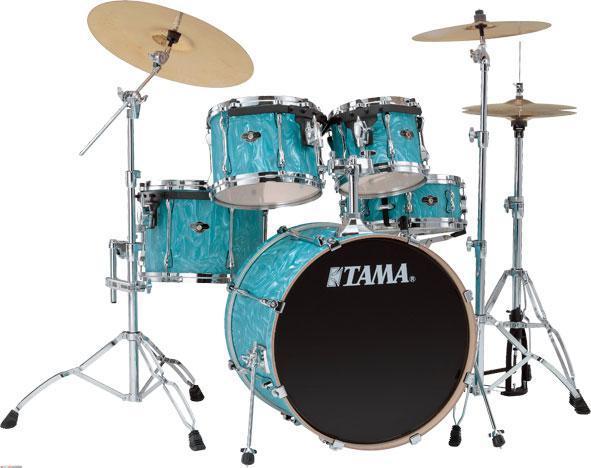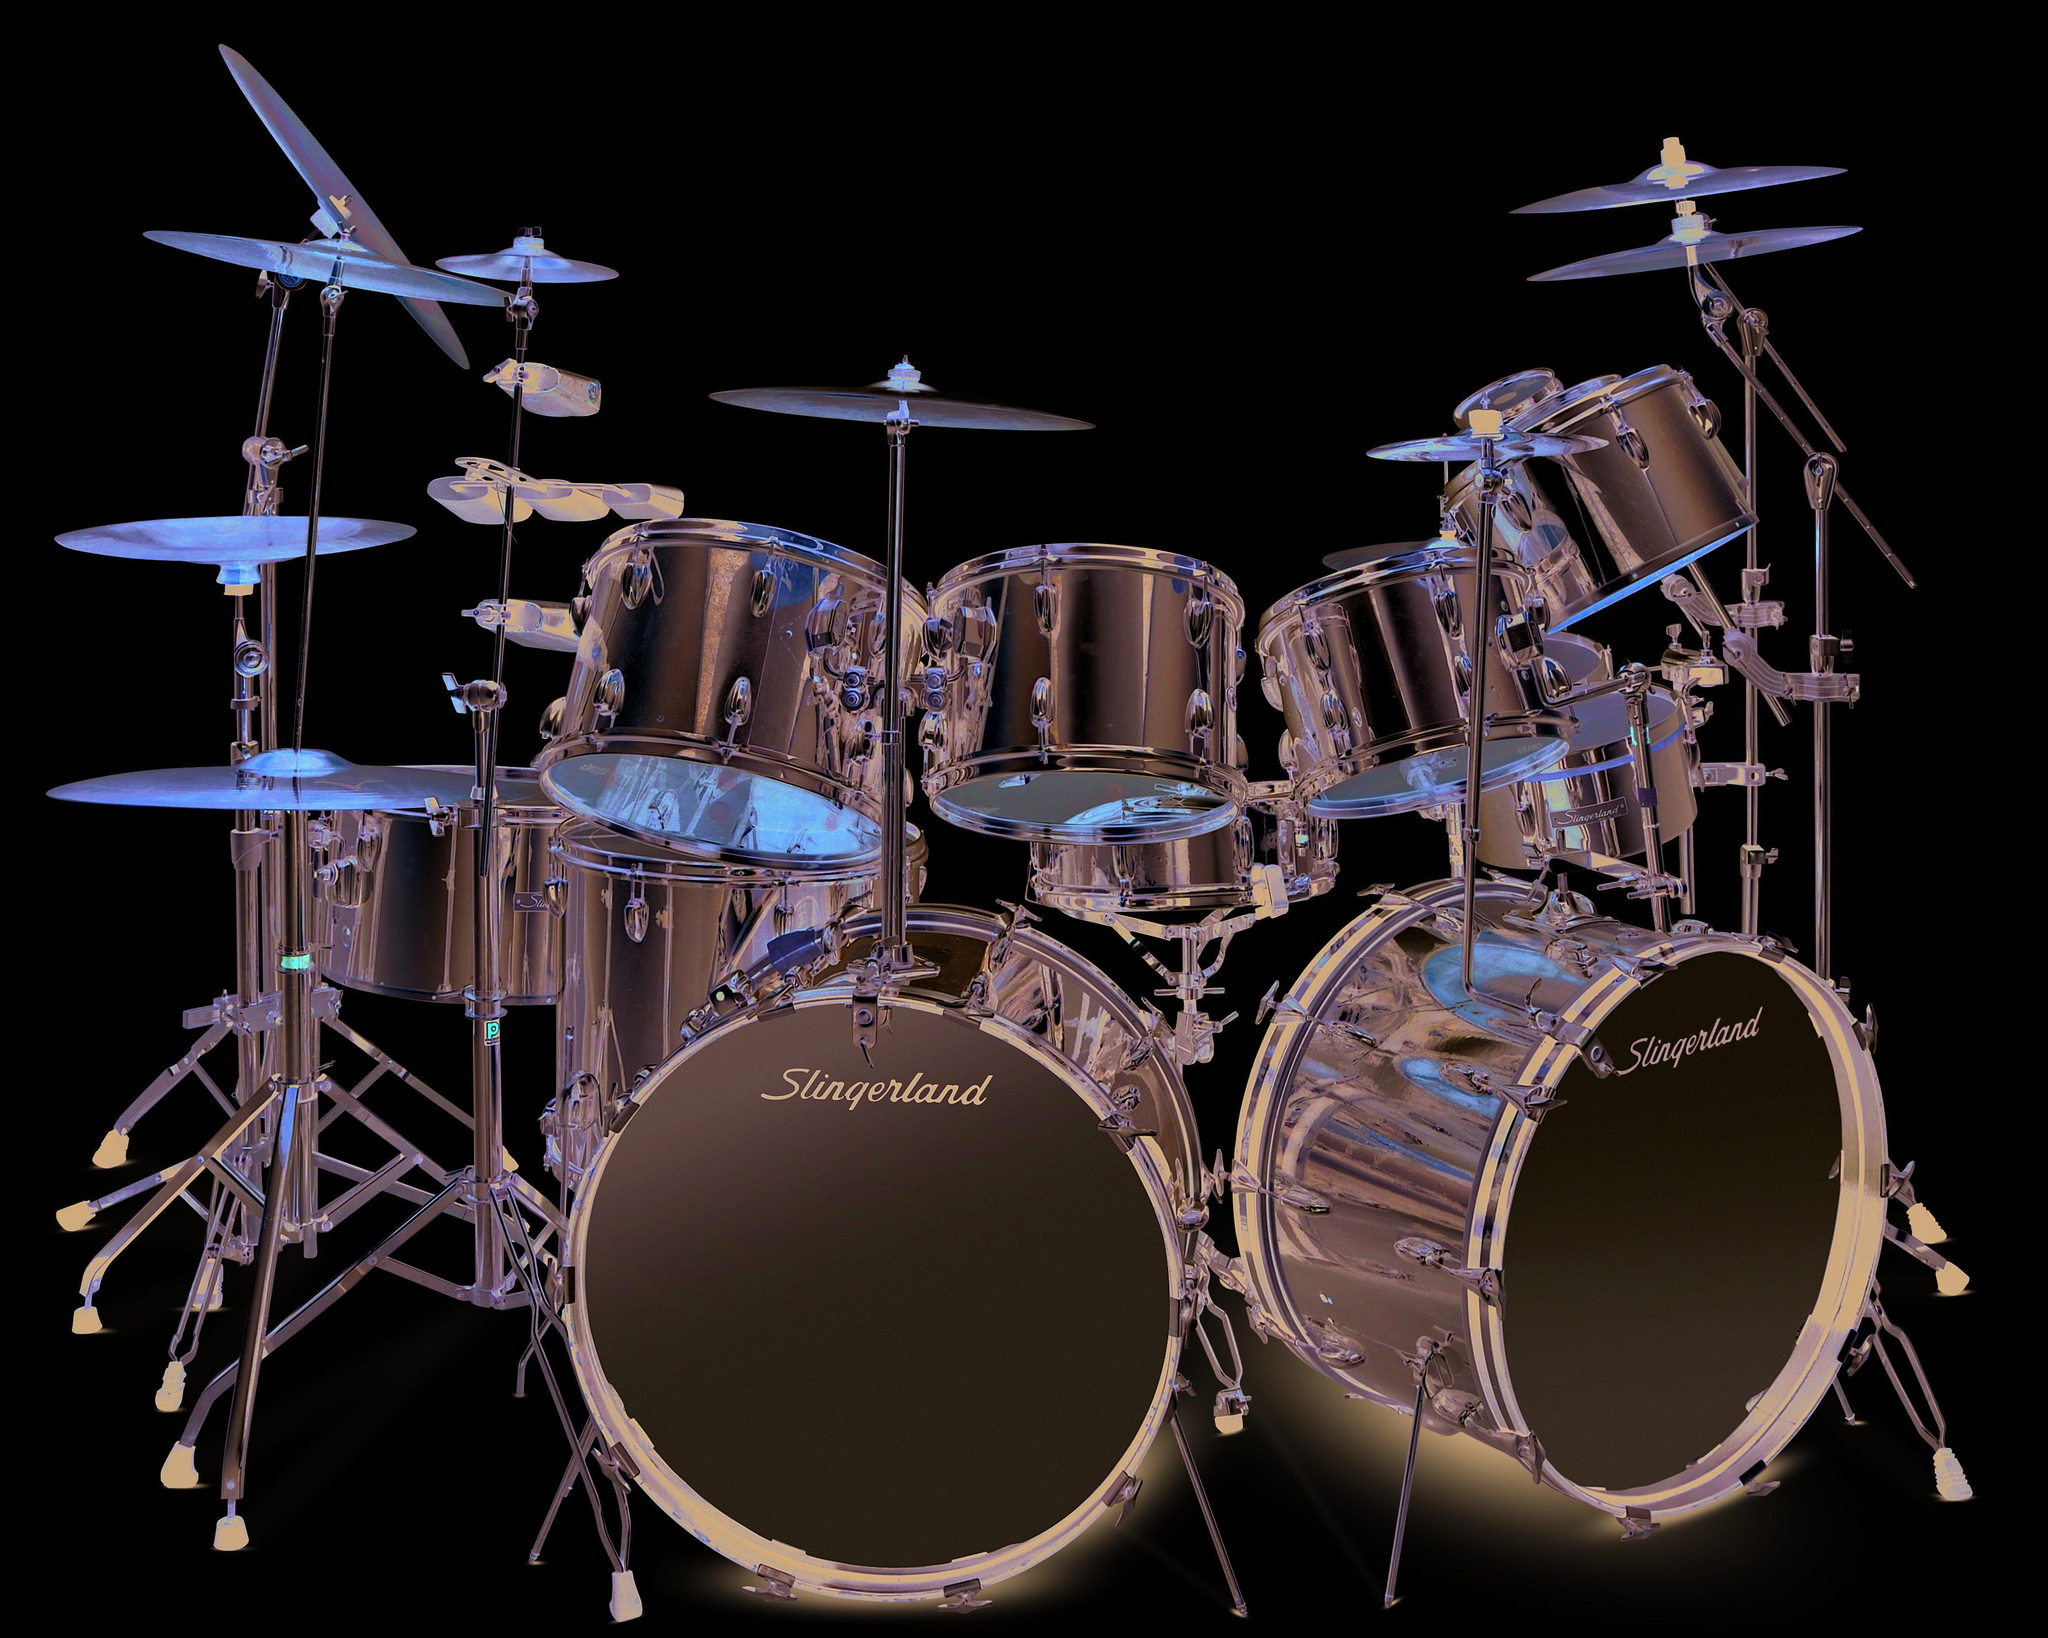The first image is the image on the left, the second image is the image on the right. For the images displayed, is the sentence "The drum kits on the left and right each have exactly one large central drum that stands with a side facing the front, and that exposed side has the same color in each image." factually correct? Answer yes or no. No. The first image is the image on the left, the second image is the image on the right. Examine the images to the left and right. Is the description "In at least one image there are five blue drums." accurate? Answer yes or no. Yes. 